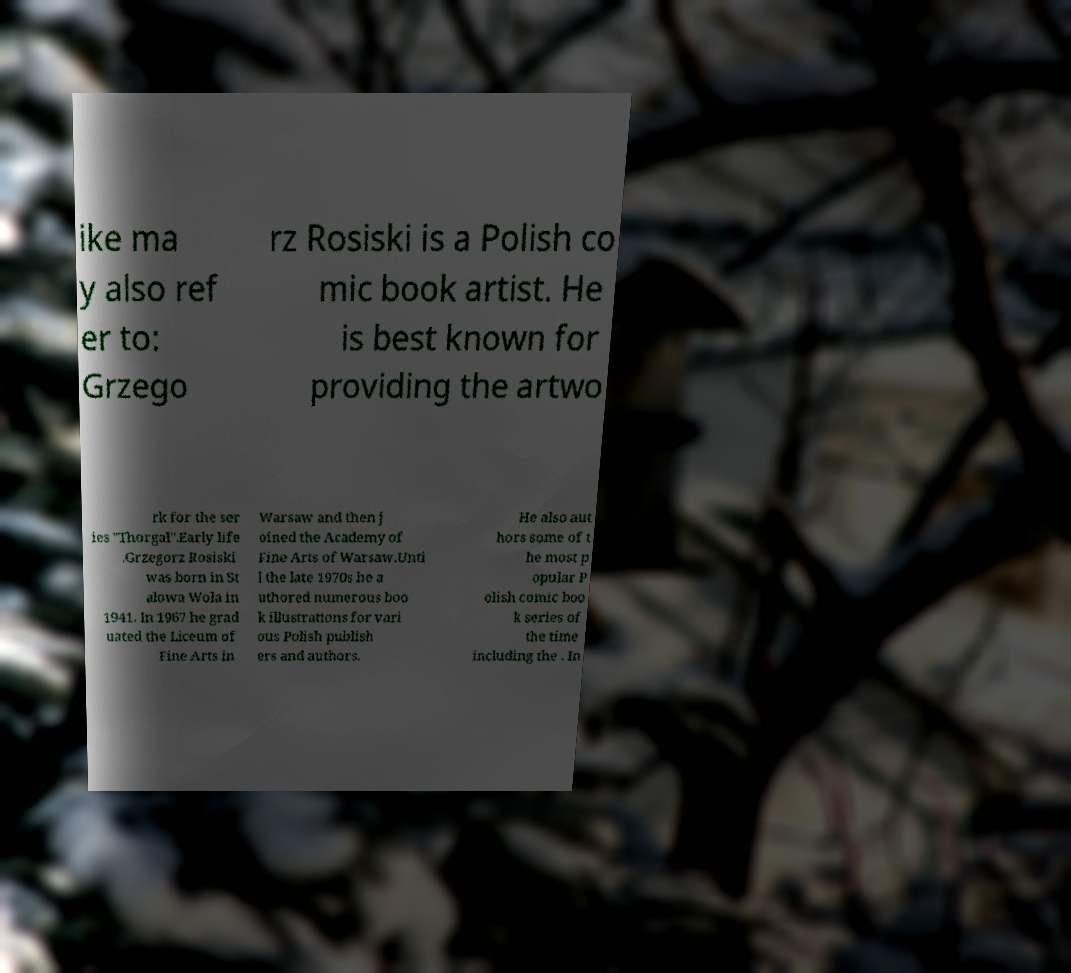Could you assist in decoding the text presented in this image and type it out clearly? ike ma y also ref er to: Grzego rz Rosiski is a Polish co mic book artist. He is best known for providing the artwo rk for the ser ies "Thorgal".Early life .Grzegorz Rosiski was born in St alowa Wola in 1941. In 1967 he grad uated the Liceum of Fine Arts in Warsaw and then j oined the Academy of Fine Arts of Warsaw.Unti l the late 1970s he a uthored numerous boo k illustrations for vari ous Polish publish ers and authors. He also aut hors some of t he most p opular P olish comic boo k series of the time including the . In 